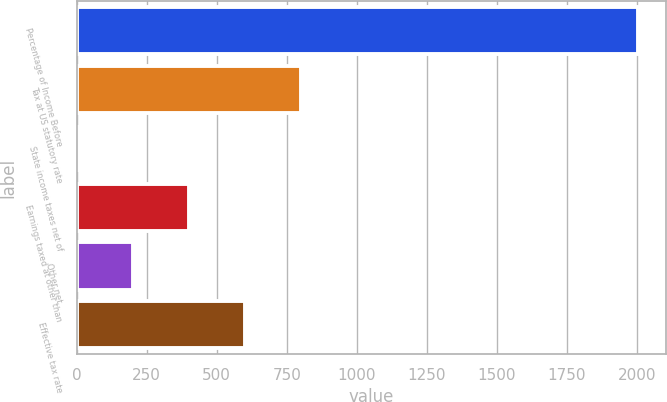<chart> <loc_0><loc_0><loc_500><loc_500><bar_chart><fcel>Percentage of Income Before<fcel>Tax at US statutory rate<fcel>State income taxes net of<fcel>Earnings taxed at other than<fcel>Other net<fcel>Effective tax rate<nl><fcel>2002<fcel>801.16<fcel>0.6<fcel>400.88<fcel>200.74<fcel>601.02<nl></chart> 